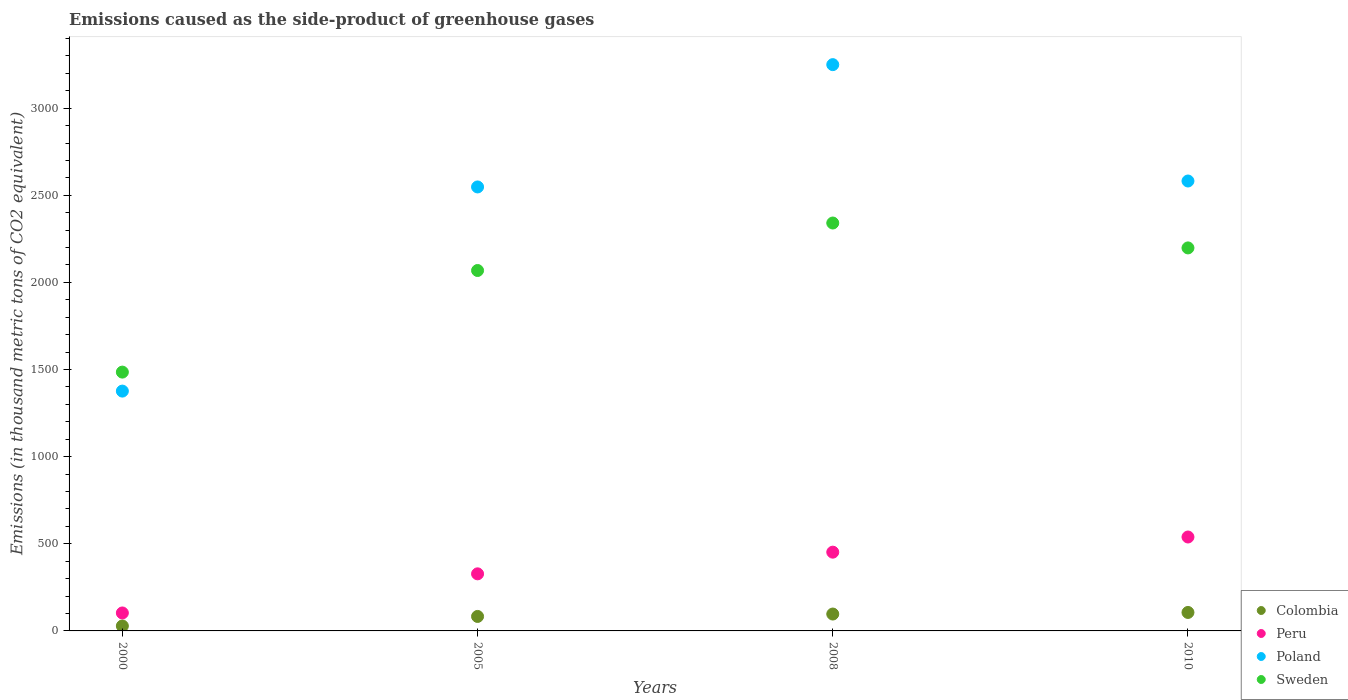What is the emissions caused as the side-product of greenhouse gases in Colombia in 2000?
Ensure brevity in your answer.  28.4. Across all years, what is the maximum emissions caused as the side-product of greenhouse gases in Peru?
Give a very brief answer. 539. Across all years, what is the minimum emissions caused as the side-product of greenhouse gases in Colombia?
Your answer should be very brief. 28.4. In which year was the emissions caused as the side-product of greenhouse gases in Poland maximum?
Make the answer very short. 2008. In which year was the emissions caused as the side-product of greenhouse gases in Poland minimum?
Keep it short and to the point. 2000. What is the total emissions caused as the side-product of greenhouse gases in Sweden in the graph?
Keep it short and to the point. 8092.6. What is the difference between the emissions caused as the side-product of greenhouse gases in Colombia in 2008 and that in 2010?
Keep it short and to the point. -9.1. What is the difference between the emissions caused as the side-product of greenhouse gases in Poland in 2000 and the emissions caused as the side-product of greenhouse gases in Colombia in 2010?
Keep it short and to the point. 1270.3. What is the average emissions caused as the side-product of greenhouse gases in Peru per year?
Make the answer very short. 355.43. In the year 2005, what is the difference between the emissions caused as the side-product of greenhouse gases in Colombia and emissions caused as the side-product of greenhouse gases in Poland?
Provide a succinct answer. -2464.8. What is the ratio of the emissions caused as the side-product of greenhouse gases in Peru in 2000 to that in 2008?
Keep it short and to the point. 0.23. Is the emissions caused as the side-product of greenhouse gases in Poland in 2000 less than that in 2005?
Provide a succinct answer. Yes. What is the difference between the highest and the second highest emissions caused as the side-product of greenhouse gases in Poland?
Offer a terse response. 667.8. What is the difference between the highest and the lowest emissions caused as the side-product of greenhouse gases in Sweden?
Your answer should be very brief. 855.6. In how many years, is the emissions caused as the side-product of greenhouse gases in Poland greater than the average emissions caused as the side-product of greenhouse gases in Poland taken over all years?
Give a very brief answer. 3. Is the sum of the emissions caused as the side-product of greenhouse gases in Colombia in 2005 and 2008 greater than the maximum emissions caused as the side-product of greenhouse gases in Sweden across all years?
Provide a succinct answer. No. Is it the case that in every year, the sum of the emissions caused as the side-product of greenhouse gases in Colombia and emissions caused as the side-product of greenhouse gases in Poland  is greater than the sum of emissions caused as the side-product of greenhouse gases in Sweden and emissions caused as the side-product of greenhouse gases in Peru?
Your response must be concise. No. Is it the case that in every year, the sum of the emissions caused as the side-product of greenhouse gases in Peru and emissions caused as the side-product of greenhouse gases in Sweden  is greater than the emissions caused as the side-product of greenhouse gases in Poland?
Keep it short and to the point. No. How many years are there in the graph?
Keep it short and to the point. 4. Are the values on the major ticks of Y-axis written in scientific E-notation?
Offer a terse response. No. Does the graph contain any zero values?
Make the answer very short. No. Does the graph contain grids?
Offer a very short reply. No. How many legend labels are there?
Offer a terse response. 4. What is the title of the graph?
Offer a terse response. Emissions caused as the side-product of greenhouse gases. Does "Cameroon" appear as one of the legend labels in the graph?
Keep it short and to the point. No. What is the label or title of the X-axis?
Your answer should be very brief. Years. What is the label or title of the Y-axis?
Provide a short and direct response. Emissions (in thousand metric tons of CO2 equivalent). What is the Emissions (in thousand metric tons of CO2 equivalent) in Colombia in 2000?
Keep it short and to the point. 28.4. What is the Emissions (in thousand metric tons of CO2 equivalent) in Peru in 2000?
Keep it short and to the point. 103.1. What is the Emissions (in thousand metric tons of CO2 equivalent) in Poland in 2000?
Your answer should be compact. 1376.3. What is the Emissions (in thousand metric tons of CO2 equivalent) of Sweden in 2000?
Make the answer very short. 1485.3. What is the Emissions (in thousand metric tons of CO2 equivalent) in Colombia in 2005?
Give a very brief answer. 83.1. What is the Emissions (in thousand metric tons of CO2 equivalent) of Peru in 2005?
Offer a terse response. 327.6. What is the Emissions (in thousand metric tons of CO2 equivalent) in Poland in 2005?
Your answer should be compact. 2547.9. What is the Emissions (in thousand metric tons of CO2 equivalent) of Sweden in 2005?
Make the answer very short. 2068.4. What is the Emissions (in thousand metric tons of CO2 equivalent) of Colombia in 2008?
Provide a succinct answer. 96.9. What is the Emissions (in thousand metric tons of CO2 equivalent) in Peru in 2008?
Provide a short and direct response. 452. What is the Emissions (in thousand metric tons of CO2 equivalent) in Poland in 2008?
Your response must be concise. 3249.8. What is the Emissions (in thousand metric tons of CO2 equivalent) of Sweden in 2008?
Offer a terse response. 2340.9. What is the Emissions (in thousand metric tons of CO2 equivalent) of Colombia in 2010?
Offer a very short reply. 106. What is the Emissions (in thousand metric tons of CO2 equivalent) in Peru in 2010?
Offer a very short reply. 539. What is the Emissions (in thousand metric tons of CO2 equivalent) in Poland in 2010?
Provide a succinct answer. 2582. What is the Emissions (in thousand metric tons of CO2 equivalent) in Sweden in 2010?
Your response must be concise. 2198. Across all years, what is the maximum Emissions (in thousand metric tons of CO2 equivalent) in Colombia?
Provide a succinct answer. 106. Across all years, what is the maximum Emissions (in thousand metric tons of CO2 equivalent) in Peru?
Offer a terse response. 539. Across all years, what is the maximum Emissions (in thousand metric tons of CO2 equivalent) of Poland?
Your answer should be compact. 3249.8. Across all years, what is the maximum Emissions (in thousand metric tons of CO2 equivalent) in Sweden?
Give a very brief answer. 2340.9. Across all years, what is the minimum Emissions (in thousand metric tons of CO2 equivalent) in Colombia?
Ensure brevity in your answer.  28.4. Across all years, what is the minimum Emissions (in thousand metric tons of CO2 equivalent) of Peru?
Offer a very short reply. 103.1. Across all years, what is the minimum Emissions (in thousand metric tons of CO2 equivalent) of Poland?
Offer a very short reply. 1376.3. Across all years, what is the minimum Emissions (in thousand metric tons of CO2 equivalent) in Sweden?
Provide a succinct answer. 1485.3. What is the total Emissions (in thousand metric tons of CO2 equivalent) of Colombia in the graph?
Ensure brevity in your answer.  314.4. What is the total Emissions (in thousand metric tons of CO2 equivalent) of Peru in the graph?
Make the answer very short. 1421.7. What is the total Emissions (in thousand metric tons of CO2 equivalent) of Poland in the graph?
Your answer should be very brief. 9756. What is the total Emissions (in thousand metric tons of CO2 equivalent) of Sweden in the graph?
Your response must be concise. 8092.6. What is the difference between the Emissions (in thousand metric tons of CO2 equivalent) in Colombia in 2000 and that in 2005?
Provide a short and direct response. -54.7. What is the difference between the Emissions (in thousand metric tons of CO2 equivalent) in Peru in 2000 and that in 2005?
Your answer should be compact. -224.5. What is the difference between the Emissions (in thousand metric tons of CO2 equivalent) in Poland in 2000 and that in 2005?
Offer a terse response. -1171.6. What is the difference between the Emissions (in thousand metric tons of CO2 equivalent) in Sweden in 2000 and that in 2005?
Provide a succinct answer. -583.1. What is the difference between the Emissions (in thousand metric tons of CO2 equivalent) in Colombia in 2000 and that in 2008?
Make the answer very short. -68.5. What is the difference between the Emissions (in thousand metric tons of CO2 equivalent) in Peru in 2000 and that in 2008?
Keep it short and to the point. -348.9. What is the difference between the Emissions (in thousand metric tons of CO2 equivalent) of Poland in 2000 and that in 2008?
Your answer should be very brief. -1873.5. What is the difference between the Emissions (in thousand metric tons of CO2 equivalent) of Sweden in 2000 and that in 2008?
Your answer should be compact. -855.6. What is the difference between the Emissions (in thousand metric tons of CO2 equivalent) in Colombia in 2000 and that in 2010?
Give a very brief answer. -77.6. What is the difference between the Emissions (in thousand metric tons of CO2 equivalent) in Peru in 2000 and that in 2010?
Provide a short and direct response. -435.9. What is the difference between the Emissions (in thousand metric tons of CO2 equivalent) in Poland in 2000 and that in 2010?
Provide a succinct answer. -1205.7. What is the difference between the Emissions (in thousand metric tons of CO2 equivalent) in Sweden in 2000 and that in 2010?
Make the answer very short. -712.7. What is the difference between the Emissions (in thousand metric tons of CO2 equivalent) of Peru in 2005 and that in 2008?
Provide a succinct answer. -124.4. What is the difference between the Emissions (in thousand metric tons of CO2 equivalent) of Poland in 2005 and that in 2008?
Your answer should be compact. -701.9. What is the difference between the Emissions (in thousand metric tons of CO2 equivalent) in Sweden in 2005 and that in 2008?
Your response must be concise. -272.5. What is the difference between the Emissions (in thousand metric tons of CO2 equivalent) in Colombia in 2005 and that in 2010?
Offer a terse response. -22.9. What is the difference between the Emissions (in thousand metric tons of CO2 equivalent) in Peru in 2005 and that in 2010?
Offer a terse response. -211.4. What is the difference between the Emissions (in thousand metric tons of CO2 equivalent) in Poland in 2005 and that in 2010?
Make the answer very short. -34.1. What is the difference between the Emissions (in thousand metric tons of CO2 equivalent) of Sweden in 2005 and that in 2010?
Provide a short and direct response. -129.6. What is the difference between the Emissions (in thousand metric tons of CO2 equivalent) in Colombia in 2008 and that in 2010?
Your response must be concise. -9.1. What is the difference between the Emissions (in thousand metric tons of CO2 equivalent) in Peru in 2008 and that in 2010?
Offer a terse response. -87. What is the difference between the Emissions (in thousand metric tons of CO2 equivalent) of Poland in 2008 and that in 2010?
Provide a succinct answer. 667.8. What is the difference between the Emissions (in thousand metric tons of CO2 equivalent) of Sweden in 2008 and that in 2010?
Your answer should be very brief. 142.9. What is the difference between the Emissions (in thousand metric tons of CO2 equivalent) in Colombia in 2000 and the Emissions (in thousand metric tons of CO2 equivalent) in Peru in 2005?
Offer a terse response. -299.2. What is the difference between the Emissions (in thousand metric tons of CO2 equivalent) in Colombia in 2000 and the Emissions (in thousand metric tons of CO2 equivalent) in Poland in 2005?
Provide a short and direct response. -2519.5. What is the difference between the Emissions (in thousand metric tons of CO2 equivalent) in Colombia in 2000 and the Emissions (in thousand metric tons of CO2 equivalent) in Sweden in 2005?
Provide a short and direct response. -2040. What is the difference between the Emissions (in thousand metric tons of CO2 equivalent) in Peru in 2000 and the Emissions (in thousand metric tons of CO2 equivalent) in Poland in 2005?
Ensure brevity in your answer.  -2444.8. What is the difference between the Emissions (in thousand metric tons of CO2 equivalent) in Peru in 2000 and the Emissions (in thousand metric tons of CO2 equivalent) in Sweden in 2005?
Offer a terse response. -1965.3. What is the difference between the Emissions (in thousand metric tons of CO2 equivalent) of Poland in 2000 and the Emissions (in thousand metric tons of CO2 equivalent) of Sweden in 2005?
Your answer should be compact. -692.1. What is the difference between the Emissions (in thousand metric tons of CO2 equivalent) of Colombia in 2000 and the Emissions (in thousand metric tons of CO2 equivalent) of Peru in 2008?
Your answer should be compact. -423.6. What is the difference between the Emissions (in thousand metric tons of CO2 equivalent) in Colombia in 2000 and the Emissions (in thousand metric tons of CO2 equivalent) in Poland in 2008?
Provide a short and direct response. -3221.4. What is the difference between the Emissions (in thousand metric tons of CO2 equivalent) of Colombia in 2000 and the Emissions (in thousand metric tons of CO2 equivalent) of Sweden in 2008?
Provide a short and direct response. -2312.5. What is the difference between the Emissions (in thousand metric tons of CO2 equivalent) in Peru in 2000 and the Emissions (in thousand metric tons of CO2 equivalent) in Poland in 2008?
Provide a short and direct response. -3146.7. What is the difference between the Emissions (in thousand metric tons of CO2 equivalent) of Peru in 2000 and the Emissions (in thousand metric tons of CO2 equivalent) of Sweden in 2008?
Make the answer very short. -2237.8. What is the difference between the Emissions (in thousand metric tons of CO2 equivalent) in Poland in 2000 and the Emissions (in thousand metric tons of CO2 equivalent) in Sweden in 2008?
Offer a very short reply. -964.6. What is the difference between the Emissions (in thousand metric tons of CO2 equivalent) in Colombia in 2000 and the Emissions (in thousand metric tons of CO2 equivalent) in Peru in 2010?
Make the answer very short. -510.6. What is the difference between the Emissions (in thousand metric tons of CO2 equivalent) of Colombia in 2000 and the Emissions (in thousand metric tons of CO2 equivalent) of Poland in 2010?
Provide a succinct answer. -2553.6. What is the difference between the Emissions (in thousand metric tons of CO2 equivalent) in Colombia in 2000 and the Emissions (in thousand metric tons of CO2 equivalent) in Sweden in 2010?
Your answer should be compact. -2169.6. What is the difference between the Emissions (in thousand metric tons of CO2 equivalent) of Peru in 2000 and the Emissions (in thousand metric tons of CO2 equivalent) of Poland in 2010?
Your response must be concise. -2478.9. What is the difference between the Emissions (in thousand metric tons of CO2 equivalent) of Peru in 2000 and the Emissions (in thousand metric tons of CO2 equivalent) of Sweden in 2010?
Keep it short and to the point. -2094.9. What is the difference between the Emissions (in thousand metric tons of CO2 equivalent) in Poland in 2000 and the Emissions (in thousand metric tons of CO2 equivalent) in Sweden in 2010?
Your answer should be very brief. -821.7. What is the difference between the Emissions (in thousand metric tons of CO2 equivalent) in Colombia in 2005 and the Emissions (in thousand metric tons of CO2 equivalent) in Peru in 2008?
Offer a terse response. -368.9. What is the difference between the Emissions (in thousand metric tons of CO2 equivalent) of Colombia in 2005 and the Emissions (in thousand metric tons of CO2 equivalent) of Poland in 2008?
Provide a short and direct response. -3166.7. What is the difference between the Emissions (in thousand metric tons of CO2 equivalent) of Colombia in 2005 and the Emissions (in thousand metric tons of CO2 equivalent) of Sweden in 2008?
Give a very brief answer. -2257.8. What is the difference between the Emissions (in thousand metric tons of CO2 equivalent) of Peru in 2005 and the Emissions (in thousand metric tons of CO2 equivalent) of Poland in 2008?
Your answer should be very brief. -2922.2. What is the difference between the Emissions (in thousand metric tons of CO2 equivalent) in Peru in 2005 and the Emissions (in thousand metric tons of CO2 equivalent) in Sweden in 2008?
Your response must be concise. -2013.3. What is the difference between the Emissions (in thousand metric tons of CO2 equivalent) of Poland in 2005 and the Emissions (in thousand metric tons of CO2 equivalent) of Sweden in 2008?
Make the answer very short. 207. What is the difference between the Emissions (in thousand metric tons of CO2 equivalent) of Colombia in 2005 and the Emissions (in thousand metric tons of CO2 equivalent) of Peru in 2010?
Ensure brevity in your answer.  -455.9. What is the difference between the Emissions (in thousand metric tons of CO2 equivalent) in Colombia in 2005 and the Emissions (in thousand metric tons of CO2 equivalent) in Poland in 2010?
Offer a very short reply. -2498.9. What is the difference between the Emissions (in thousand metric tons of CO2 equivalent) of Colombia in 2005 and the Emissions (in thousand metric tons of CO2 equivalent) of Sweden in 2010?
Offer a very short reply. -2114.9. What is the difference between the Emissions (in thousand metric tons of CO2 equivalent) in Peru in 2005 and the Emissions (in thousand metric tons of CO2 equivalent) in Poland in 2010?
Your answer should be very brief. -2254.4. What is the difference between the Emissions (in thousand metric tons of CO2 equivalent) in Peru in 2005 and the Emissions (in thousand metric tons of CO2 equivalent) in Sweden in 2010?
Provide a short and direct response. -1870.4. What is the difference between the Emissions (in thousand metric tons of CO2 equivalent) in Poland in 2005 and the Emissions (in thousand metric tons of CO2 equivalent) in Sweden in 2010?
Keep it short and to the point. 349.9. What is the difference between the Emissions (in thousand metric tons of CO2 equivalent) of Colombia in 2008 and the Emissions (in thousand metric tons of CO2 equivalent) of Peru in 2010?
Give a very brief answer. -442.1. What is the difference between the Emissions (in thousand metric tons of CO2 equivalent) of Colombia in 2008 and the Emissions (in thousand metric tons of CO2 equivalent) of Poland in 2010?
Ensure brevity in your answer.  -2485.1. What is the difference between the Emissions (in thousand metric tons of CO2 equivalent) in Colombia in 2008 and the Emissions (in thousand metric tons of CO2 equivalent) in Sweden in 2010?
Give a very brief answer. -2101.1. What is the difference between the Emissions (in thousand metric tons of CO2 equivalent) of Peru in 2008 and the Emissions (in thousand metric tons of CO2 equivalent) of Poland in 2010?
Give a very brief answer. -2130. What is the difference between the Emissions (in thousand metric tons of CO2 equivalent) of Peru in 2008 and the Emissions (in thousand metric tons of CO2 equivalent) of Sweden in 2010?
Give a very brief answer. -1746. What is the difference between the Emissions (in thousand metric tons of CO2 equivalent) of Poland in 2008 and the Emissions (in thousand metric tons of CO2 equivalent) of Sweden in 2010?
Offer a very short reply. 1051.8. What is the average Emissions (in thousand metric tons of CO2 equivalent) in Colombia per year?
Give a very brief answer. 78.6. What is the average Emissions (in thousand metric tons of CO2 equivalent) in Peru per year?
Make the answer very short. 355.43. What is the average Emissions (in thousand metric tons of CO2 equivalent) in Poland per year?
Make the answer very short. 2439. What is the average Emissions (in thousand metric tons of CO2 equivalent) of Sweden per year?
Keep it short and to the point. 2023.15. In the year 2000, what is the difference between the Emissions (in thousand metric tons of CO2 equivalent) of Colombia and Emissions (in thousand metric tons of CO2 equivalent) of Peru?
Give a very brief answer. -74.7. In the year 2000, what is the difference between the Emissions (in thousand metric tons of CO2 equivalent) in Colombia and Emissions (in thousand metric tons of CO2 equivalent) in Poland?
Make the answer very short. -1347.9. In the year 2000, what is the difference between the Emissions (in thousand metric tons of CO2 equivalent) in Colombia and Emissions (in thousand metric tons of CO2 equivalent) in Sweden?
Provide a succinct answer. -1456.9. In the year 2000, what is the difference between the Emissions (in thousand metric tons of CO2 equivalent) in Peru and Emissions (in thousand metric tons of CO2 equivalent) in Poland?
Provide a succinct answer. -1273.2. In the year 2000, what is the difference between the Emissions (in thousand metric tons of CO2 equivalent) in Peru and Emissions (in thousand metric tons of CO2 equivalent) in Sweden?
Ensure brevity in your answer.  -1382.2. In the year 2000, what is the difference between the Emissions (in thousand metric tons of CO2 equivalent) of Poland and Emissions (in thousand metric tons of CO2 equivalent) of Sweden?
Your answer should be very brief. -109. In the year 2005, what is the difference between the Emissions (in thousand metric tons of CO2 equivalent) of Colombia and Emissions (in thousand metric tons of CO2 equivalent) of Peru?
Ensure brevity in your answer.  -244.5. In the year 2005, what is the difference between the Emissions (in thousand metric tons of CO2 equivalent) of Colombia and Emissions (in thousand metric tons of CO2 equivalent) of Poland?
Make the answer very short. -2464.8. In the year 2005, what is the difference between the Emissions (in thousand metric tons of CO2 equivalent) of Colombia and Emissions (in thousand metric tons of CO2 equivalent) of Sweden?
Ensure brevity in your answer.  -1985.3. In the year 2005, what is the difference between the Emissions (in thousand metric tons of CO2 equivalent) in Peru and Emissions (in thousand metric tons of CO2 equivalent) in Poland?
Keep it short and to the point. -2220.3. In the year 2005, what is the difference between the Emissions (in thousand metric tons of CO2 equivalent) of Peru and Emissions (in thousand metric tons of CO2 equivalent) of Sweden?
Offer a terse response. -1740.8. In the year 2005, what is the difference between the Emissions (in thousand metric tons of CO2 equivalent) of Poland and Emissions (in thousand metric tons of CO2 equivalent) of Sweden?
Ensure brevity in your answer.  479.5. In the year 2008, what is the difference between the Emissions (in thousand metric tons of CO2 equivalent) in Colombia and Emissions (in thousand metric tons of CO2 equivalent) in Peru?
Keep it short and to the point. -355.1. In the year 2008, what is the difference between the Emissions (in thousand metric tons of CO2 equivalent) of Colombia and Emissions (in thousand metric tons of CO2 equivalent) of Poland?
Your answer should be very brief. -3152.9. In the year 2008, what is the difference between the Emissions (in thousand metric tons of CO2 equivalent) of Colombia and Emissions (in thousand metric tons of CO2 equivalent) of Sweden?
Provide a short and direct response. -2244. In the year 2008, what is the difference between the Emissions (in thousand metric tons of CO2 equivalent) of Peru and Emissions (in thousand metric tons of CO2 equivalent) of Poland?
Provide a succinct answer. -2797.8. In the year 2008, what is the difference between the Emissions (in thousand metric tons of CO2 equivalent) of Peru and Emissions (in thousand metric tons of CO2 equivalent) of Sweden?
Make the answer very short. -1888.9. In the year 2008, what is the difference between the Emissions (in thousand metric tons of CO2 equivalent) of Poland and Emissions (in thousand metric tons of CO2 equivalent) of Sweden?
Your answer should be compact. 908.9. In the year 2010, what is the difference between the Emissions (in thousand metric tons of CO2 equivalent) in Colombia and Emissions (in thousand metric tons of CO2 equivalent) in Peru?
Make the answer very short. -433. In the year 2010, what is the difference between the Emissions (in thousand metric tons of CO2 equivalent) in Colombia and Emissions (in thousand metric tons of CO2 equivalent) in Poland?
Offer a terse response. -2476. In the year 2010, what is the difference between the Emissions (in thousand metric tons of CO2 equivalent) in Colombia and Emissions (in thousand metric tons of CO2 equivalent) in Sweden?
Offer a very short reply. -2092. In the year 2010, what is the difference between the Emissions (in thousand metric tons of CO2 equivalent) in Peru and Emissions (in thousand metric tons of CO2 equivalent) in Poland?
Your response must be concise. -2043. In the year 2010, what is the difference between the Emissions (in thousand metric tons of CO2 equivalent) of Peru and Emissions (in thousand metric tons of CO2 equivalent) of Sweden?
Provide a short and direct response. -1659. In the year 2010, what is the difference between the Emissions (in thousand metric tons of CO2 equivalent) of Poland and Emissions (in thousand metric tons of CO2 equivalent) of Sweden?
Keep it short and to the point. 384. What is the ratio of the Emissions (in thousand metric tons of CO2 equivalent) of Colombia in 2000 to that in 2005?
Your answer should be very brief. 0.34. What is the ratio of the Emissions (in thousand metric tons of CO2 equivalent) in Peru in 2000 to that in 2005?
Provide a succinct answer. 0.31. What is the ratio of the Emissions (in thousand metric tons of CO2 equivalent) of Poland in 2000 to that in 2005?
Make the answer very short. 0.54. What is the ratio of the Emissions (in thousand metric tons of CO2 equivalent) in Sweden in 2000 to that in 2005?
Provide a succinct answer. 0.72. What is the ratio of the Emissions (in thousand metric tons of CO2 equivalent) of Colombia in 2000 to that in 2008?
Offer a very short reply. 0.29. What is the ratio of the Emissions (in thousand metric tons of CO2 equivalent) in Peru in 2000 to that in 2008?
Give a very brief answer. 0.23. What is the ratio of the Emissions (in thousand metric tons of CO2 equivalent) of Poland in 2000 to that in 2008?
Make the answer very short. 0.42. What is the ratio of the Emissions (in thousand metric tons of CO2 equivalent) in Sweden in 2000 to that in 2008?
Keep it short and to the point. 0.63. What is the ratio of the Emissions (in thousand metric tons of CO2 equivalent) in Colombia in 2000 to that in 2010?
Give a very brief answer. 0.27. What is the ratio of the Emissions (in thousand metric tons of CO2 equivalent) in Peru in 2000 to that in 2010?
Your answer should be very brief. 0.19. What is the ratio of the Emissions (in thousand metric tons of CO2 equivalent) of Poland in 2000 to that in 2010?
Give a very brief answer. 0.53. What is the ratio of the Emissions (in thousand metric tons of CO2 equivalent) of Sweden in 2000 to that in 2010?
Give a very brief answer. 0.68. What is the ratio of the Emissions (in thousand metric tons of CO2 equivalent) in Colombia in 2005 to that in 2008?
Ensure brevity in your answer.  0.86. What is the ratio of the Emissions (in thousand metric tons of CO2 equivalent) in Peru in 2005 to that in 2008?
Your answer should be very brief. 0.72. What is the ratio of the Emissions (in thousand metric tons of CO2 equivalent) of Poland in 2005 to that in 2008?
Your answer should be compact. 0.78. What is the ratio of the Emissions (in thousand metric tons of CO2 equivalent) in Sweden in 2005 to that in 2008?
Provide a succinct answer. 0.88. What is the ratio of the Emissions (in thousand metric tons of CO2 equivalent) of Colombia in 2005 to that in 2010?
Provide a short and direct response. 0.78. What is the ratio of the Emissions (in thousand metric tons of CO2 equivalent) of Peru in 2005 to that in 2010?
Offer a terse response. 0.61. What is the ratio of the Emissions (in thousand metric tons of CO2 equivalent) in Sweden in 2005 to that in 2010?
Provide a short and direct response. 0.94. What is the ratio of the Emissions (in thousand metric tons of CO2 equivalent) in Colombia in 2008 to that in 2010?
Provide a short and direct response. 0.91. What is the ratio of the Emissions (in thousand metric tons of CO2 equivalent) in Peru in 2008 to that in 2010?
Keep it short and to the point. 0.84. What is the ratio of the Emissions (in thousand metric tons of CO2 equivalent) of Poland in 2008 to that in 2010?
Give a very brief answer. 1.26. What is the ratio of the Emissions (in thousand metric tons of CO2 equivalent) in Sweden in 2008 to that in 2010?
Your answer should be compact. 1.06. What is the difference between the highest and the second highest Emissions (in thousand metric tons of CO2 equivalent) in Peru?
Offer a very short reply. 87. What is the difference between the highest and the second highest Emissions (in thousand metric tons of CO2 equivalent) in Poland?
Give a very brief answer. 667.8. What is the difference between the highest and the second highest Emissions (in thousand metric tons of CO2 equivalent) in Sweden?
Offer a terse response. 142.9. What is the difference between the highest and the lowest Emissions (in thousand metric tons of CO2 equivalent) in Colombia?
Your answer should be compact. 77.6. What is the difference between the highest and the lowest Emissions (in thousand metric tons of CO2 equivalent) of Peru?
Give a very brief answer. 435.9. What is the difference between the highest and the lowest Emissions (in thousand metric tons of CO2 equivalent) of Poland?
Offer a very short reply. 1873.5. What is the difference between the highest and the lowest Emissions (in thousand metric tons of CO2 equivalent) of Sweden?
Provide a succinct answer. 855.6. 